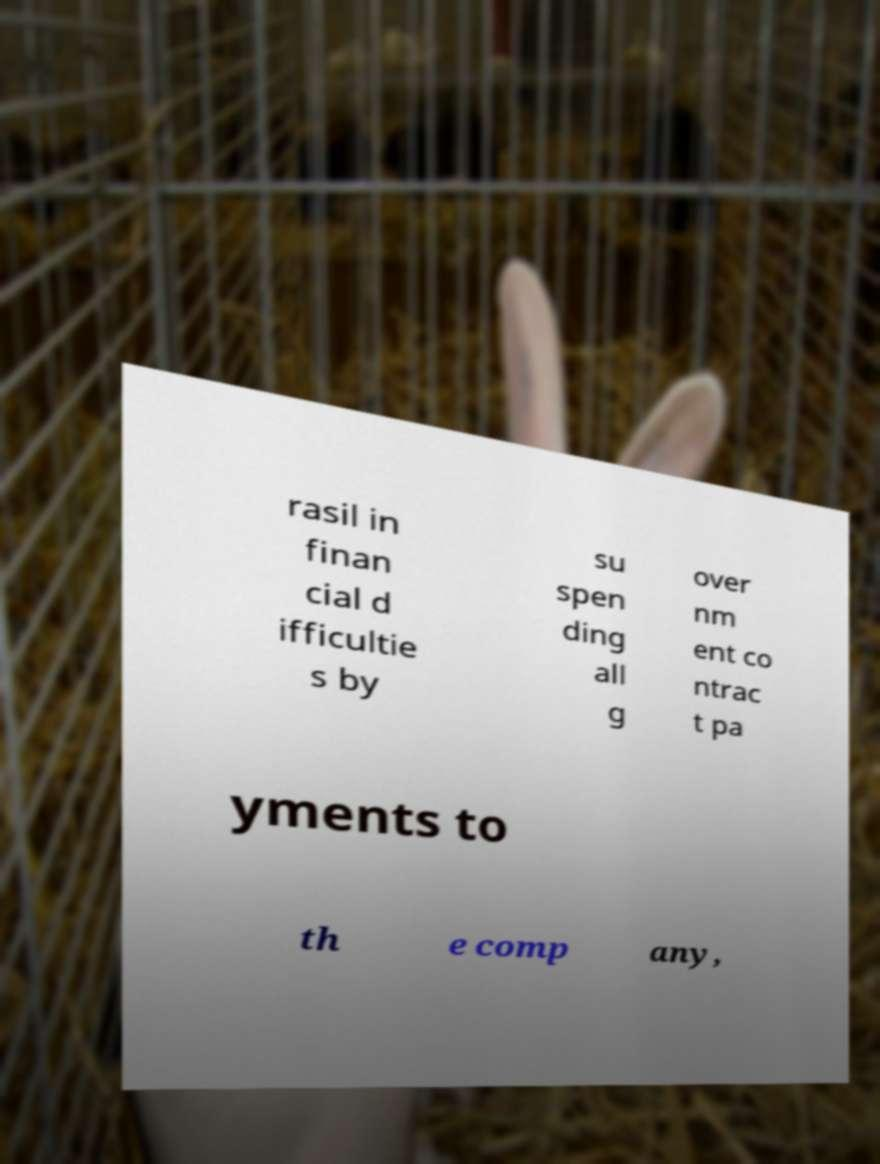Can you read and provide the text displayed in the image?This photo seems to have some interesting text. Can you extract and type it out for me? rasil in finan cial d ifficultie s by su spen ding all g over nm ent co ntrac t pa yments to th e comp any, 